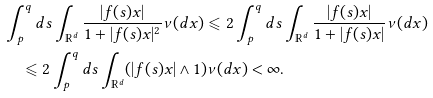Convert formula to latex. <formula><loc_0><loc_0><loc_500><loc_500>& \int _ { p } ^ { q } d s \int _ { \mathbb { R } ^ { d } } \frac { | f ( s ) x | } { 1 + | f ( s ) x | ^ { 2 } } \nu ( d x ) \leqslant 2 \int _ { p } ^ { q } d s \int _ { \mathbb { R } ^ { d } } \frac { | f ( s ) x | } { 1 + | f ( s ) x | } \nu ( d x ) \\ & \quad \leqslant 2 \int _ { p } ^ { q } d s \int _ { \mathbb { R } ^ { d } } ( | f ( s ) x | \land 1 ) \nu ( d x ) < \infty .</formula> 